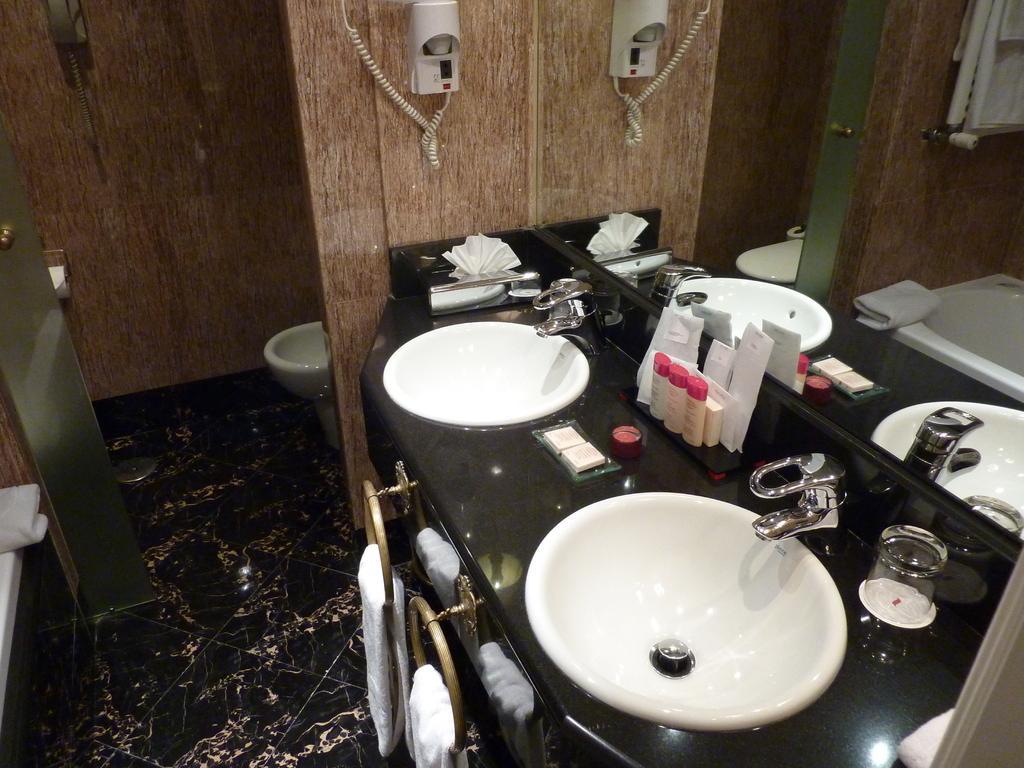Can you describe this image briefly? In this image, I can see two wash basins, taps, napkins, bottles and few other things on a bathroom vanity. At the bottom of the image, there are napkins hanging to the hangers and I can see a floor. At the top of the image, I can see a hand shower and an object are attached to the walls. Behind the wall, I can see a toilet seat. On the left side of the image, there is a toilet paper roll, glass door and a cloth. 